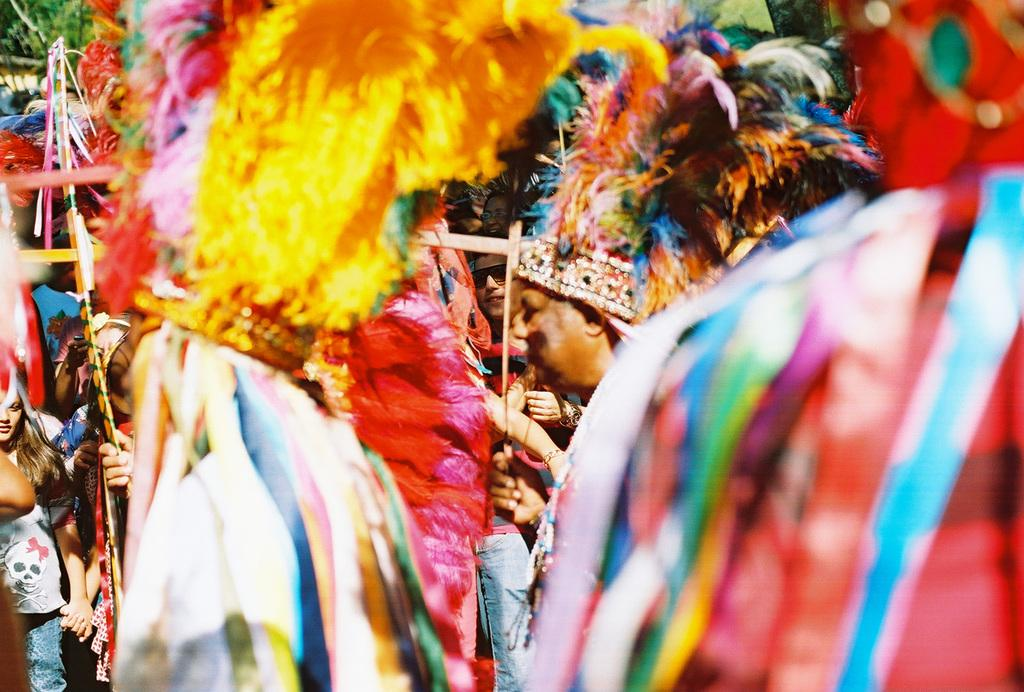Who is present in the image? There are people in the image. What are the people wearing? The people are wearing costumes. What are the people holding in the image? The people are holding objects. What can be seen at the top left side of the image? There are leaves at the top left side of the image. How many yams are being held by the people in the image? There is no yam present in the image; the people are holding objects, but they are not yams. Are the people in the image brothers? The provided facts do not mention any familial relationships between the people in the image, so we cannot determine if they are brothers. 